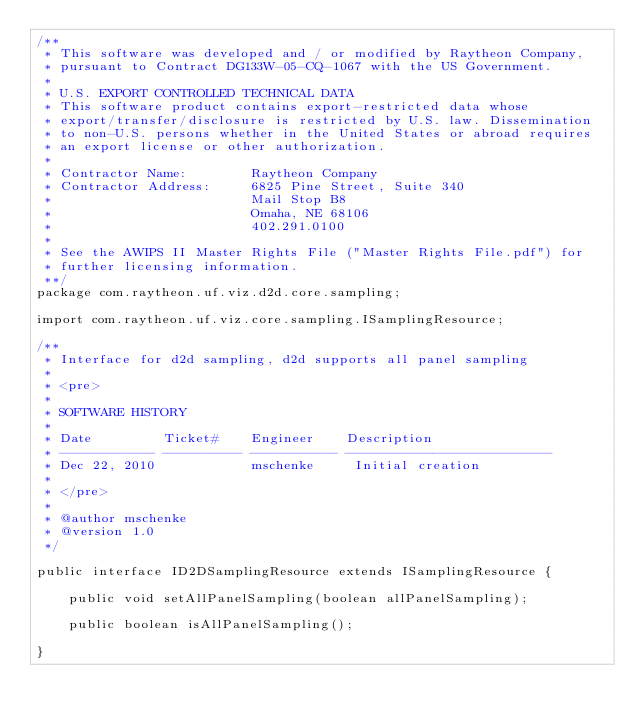<code> <loc_0><loc_0><loc_500><loc_500><_Java_>/**
 * This software was developed and / or modified by Raytheon Company,
 * pursuant to Contract DG133W-05-CQ-1067 with the US Government.
 * 
 * U.S. EXPORT CONTROLLED TECHNICAL DATA
 * This software product contains export-restricted data whose
 * export/transfer/disclosure is restricted by U.S. law. Dissemination
 * to non-U.S. persons whether in the United States or abroad requires
 * an export license or other authorization.
 * 
 * Contractor Name:        Raytheon Company
 * Contractor Address:     6825 Pine Street, Suite 340
 *                         Mail Stop B8
 *                         Omaha, NE 68106
 *                         402.291.0100
 * 
 * See the AWIPS II Master Rights File ("Master Rights File.pdf") for
 * further licensing information.
 **/
package com.raytheon.uf.viz.d2d.core.sampling;

import com.raytheon.uf.viz.core.sampling.ISamplingResource;

/**
 * Interface for d2d sampling, d2d supports all panel sampling
 * 
 * <pre>
 * 
 * SOFTWARE HISTORY
 * 
 * Date         Ticket#    Engineer    Description
 * ------------ ---------- ----------- --------------------------
 * Dec 22, 2010            mschenke     Initial creation
 * 
 * </pre>
 * 
 * @author mschenke
 * @version 1.0
 */

public interface ID2DSamplingResource extends ISamplingResource {

    public void setAllPanelSampling(boolean allPanelSampling);

    public boolean isAllPanelSampling();

}
</code> 